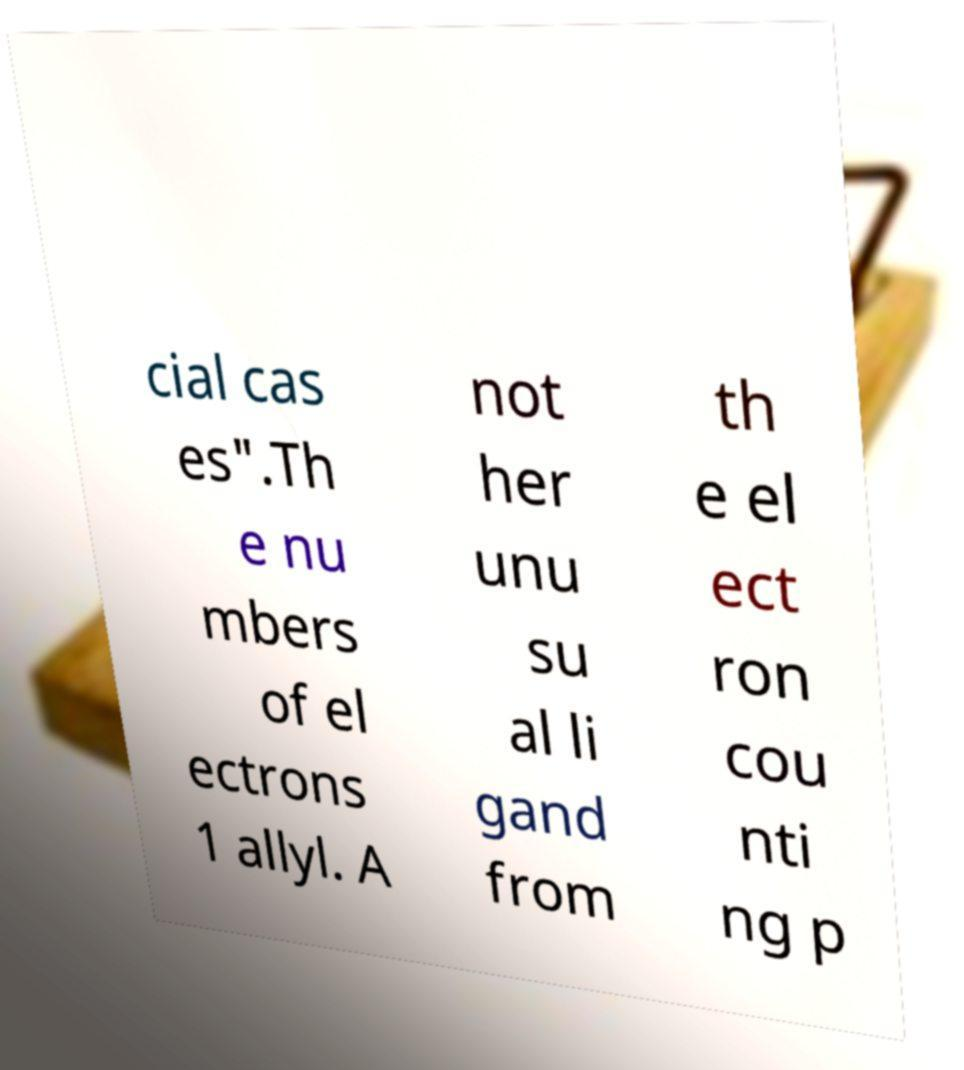Could you assist in decoding the text presented in this image and type it out clearly? cial cas es".Th e nu mbers of el ectrons 1 allyl. A not her unu su al li gand from th e el ect ron cou nti ng p 